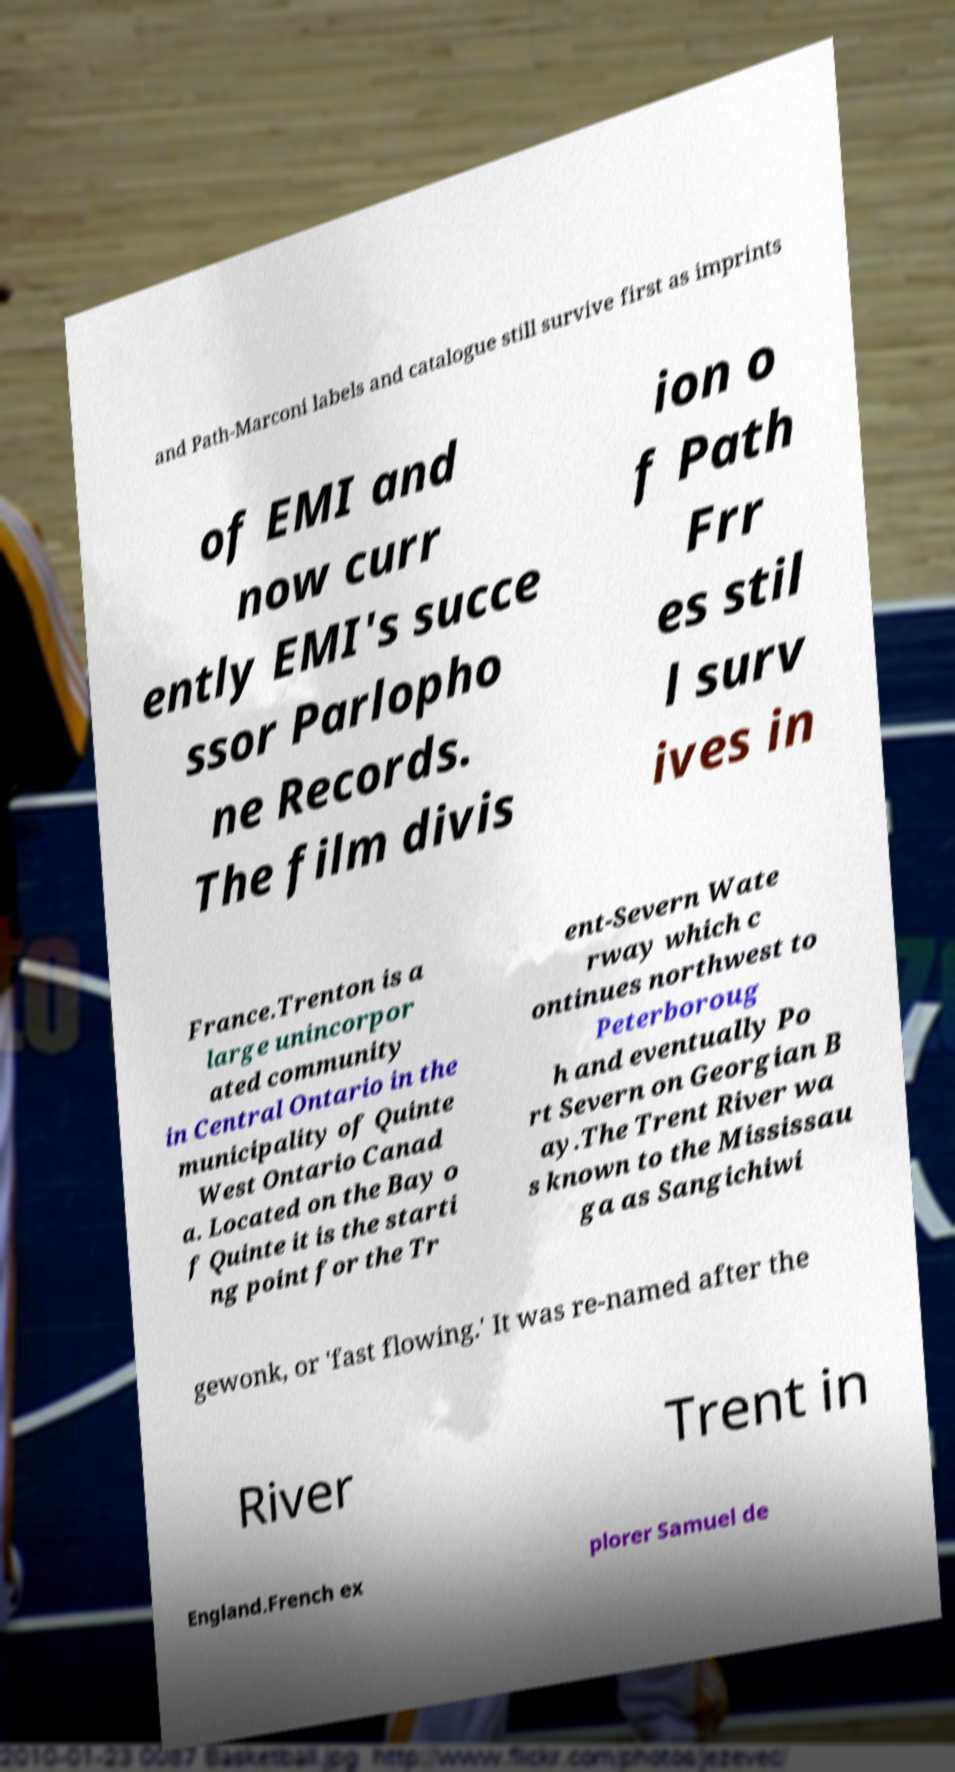There's text embedded in this image that I need extracted. Can you transcribe it verbatim? and Path-Marconi labels and catalogue still survive first as imprints of EMI and now curr ently EMI's succe ssor Parlopho ne Records. The film divis ion o f Path Frr es stil l surv ives in France.Trenton is a large unincorpor ated community in Central Ontario in the municipality of Quinte West Ontario Canad a. Located on the Bay o f Quinte it is the starti ng point for the Tr ent-Severn Wate rway which c ontinues northwest to Peterboroug h and eventually Po rt Severn on Georgian B ay.The Trent River wa s known to the Mississau ga as Sangichiwi gewonk, or 'fast flowing.' It was re-named after the River Trent in England.French ex plorer Samuel de 